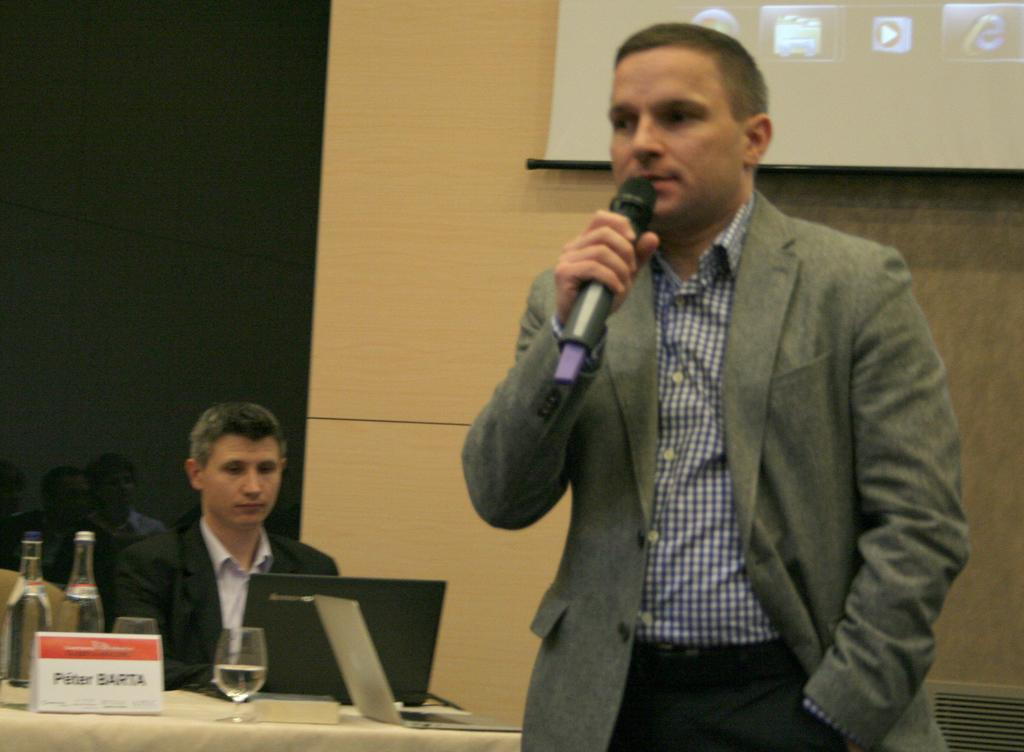What is the main object in the image? There is a screen in the image. What is the man in the image doing? A man is standing and holding a microphone. What is on the table in the image? There are glasses, bottles, and a laptop on the table. Can you describe the table in the image? There is a table in the image. What type of shoe is the man wearing in the image? There is no information about the man's shoes in the image, so we cannot determine what type of shoe he is wearing. 